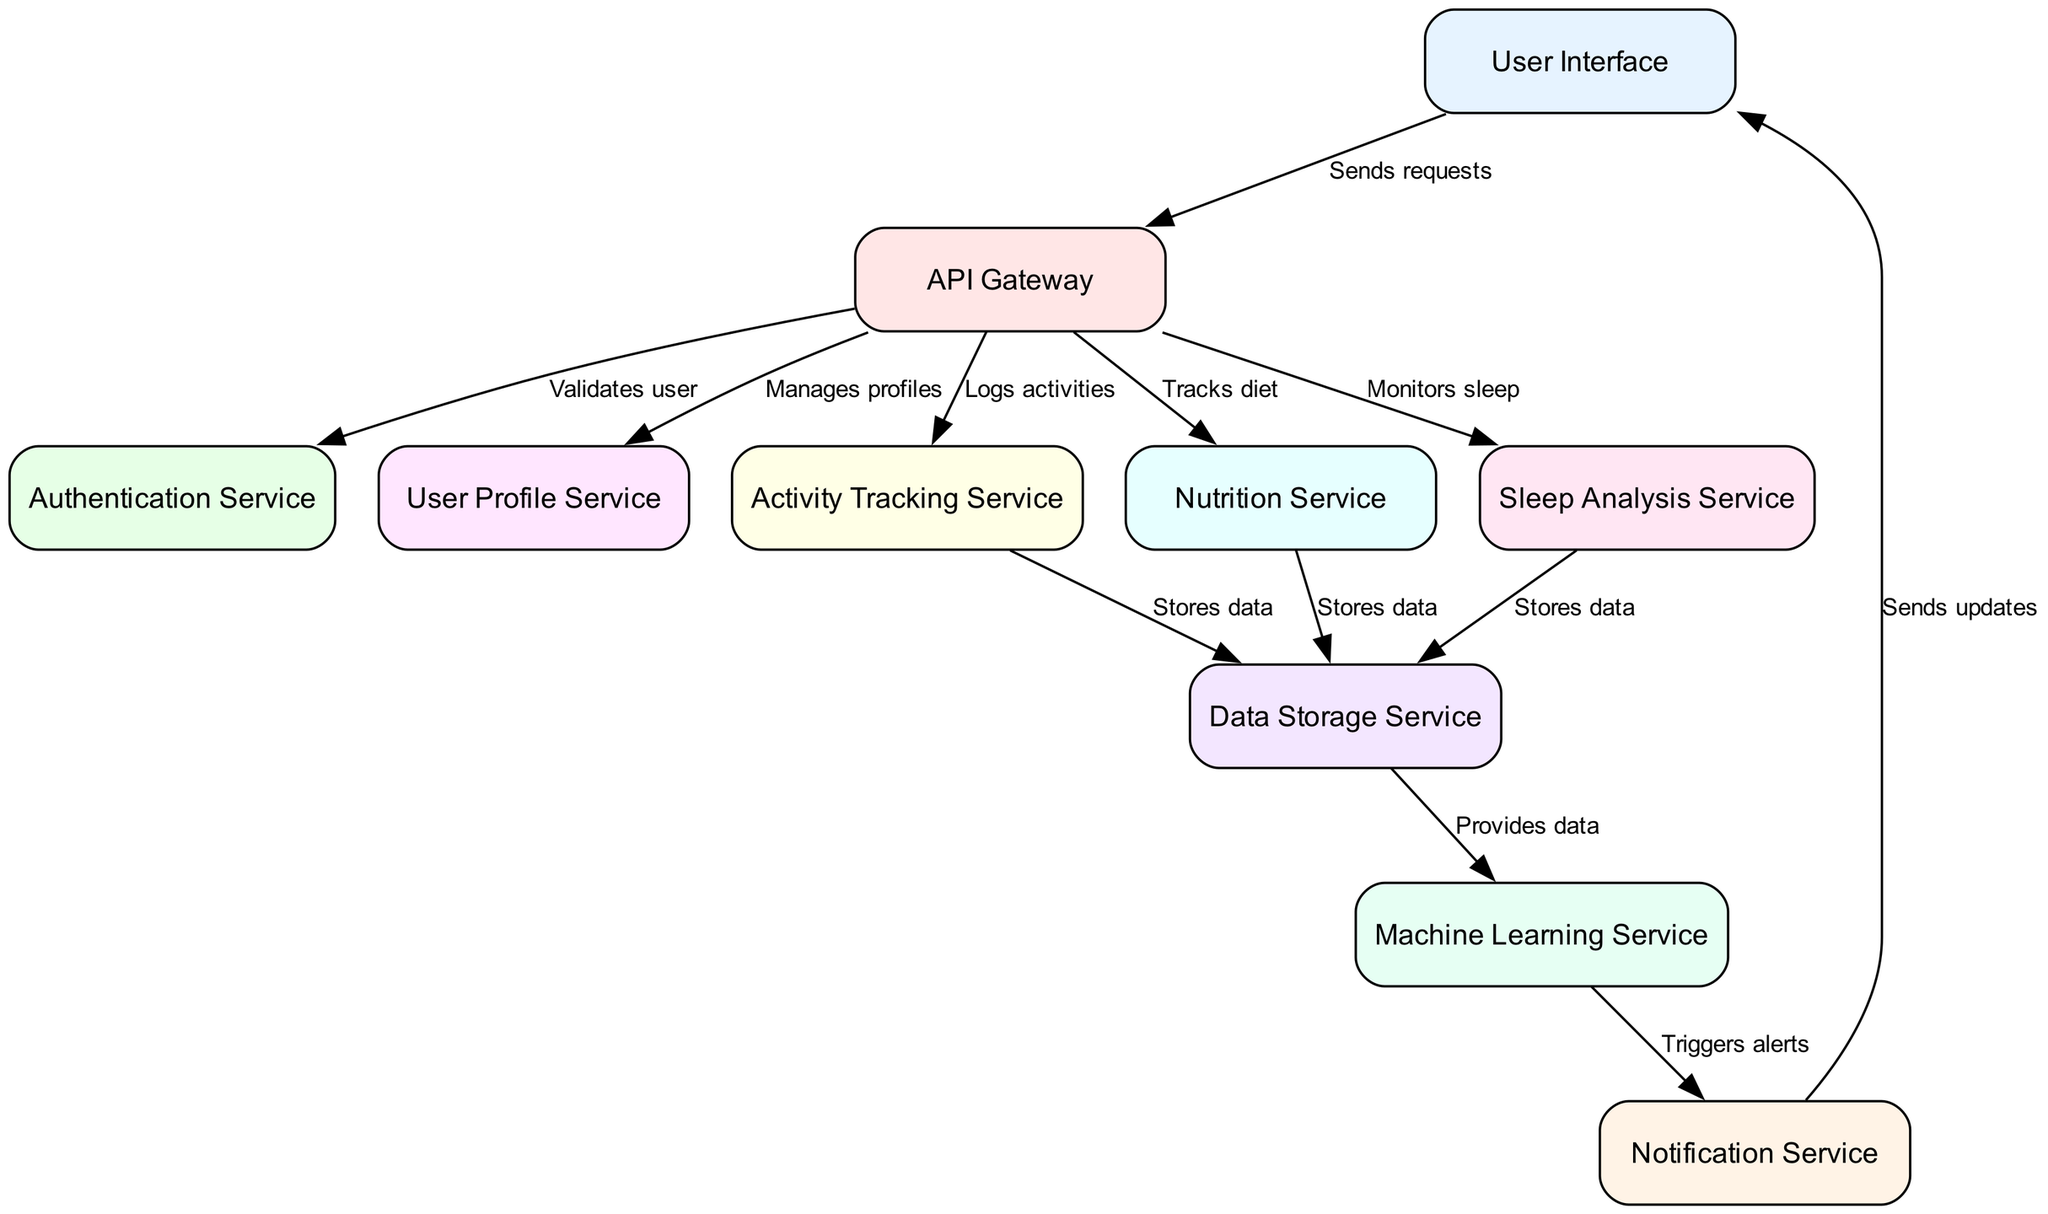What is the total number of nodes in the diagram? Counting the elements listed in the "nodes" attribute, we confirm there are ten distinct services represented in the diagram.
Answer: 10 Which service manages user profiles? The edge from the API Gateway to the User Profile Service indicates that this specific service is responsible for managing user profiles.
Answer: User Profile Service How many services store data in the Data Storage Service? Three services: Activity Tracking Service, Nutrition Service, and Sleep Analysis Service have edges that point to Data Storage Service, indicating they all store data there.
Answer: 3 What is the role of the Machine Learning Service? The Machine Learning Service receives data from the Data Storage Service and triggers alerts, which indicates its function is to analyze data and notify users based on that analysis.
Answer: Triggers alerts Which service does the Notification Service send updates to? The edge from Notification Service to User Interface indicates that it sends updates back to the user interface, allowing users to receive notifications.
Answer: User Interface Which service validates user authentication? The edge labeled that connects API Gateway with Authentication Service indicates that this service is responsible for validating user credentials.
Answer: Authentication Service What is the relationship between Activity Tracking Service and Data Storage Service? There is a directed edge from Activity Tracking Service to Data Storage Service indicating that the Activity Tracking Service stores data in the Data Storage Service.
Answer: Stores data How many total edges are present in the diagram? Counting the relationships defined in the edges attribute, there are a total of twelve connections between different nodes, which indicate how they interact with each other.
Answer: 12 What do users send requests to? The User Interface node connects to the API Gateway, which signifies that users send their requests to the API Gateway.
Answer: API Gateway How does the system notify users of any alerts? After processing data, the Machine Learning Service triggers alerts that the Notification Service then sends to the User Interface for user notifications.
Answer: Via Notification Service 